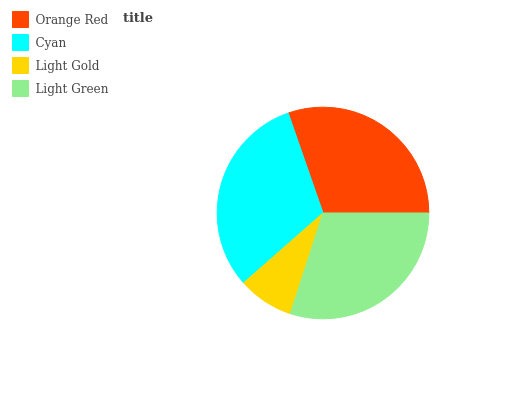Is Light Gold the minimum?
Answer yes or no. Yes. Is Cyan the maximum?
Answer yes or no. Yes. Is Cyan the minimum?
Answer yes or no. No. Is Light Gold the maximum?
Answer yes or no. No. Is Cyan greater than Light Gold?
Answer yes or no. Yes. Is Light Gold less than Cyan?
Answer yes or no. Yes. Is Light Gold greater than Cyan?
Answer yes or no. No. Is Cyan less than Light Gold?
Answer yes or no. No. Is Orange Red the high median?
Answer yes or no. Yes. Is Light Green the low median?
Answer yes or no. Yes. Is Light Gold the high median?
Answer yes or no. No. Is Orange Red the low median?
Answer yes or no. No. 